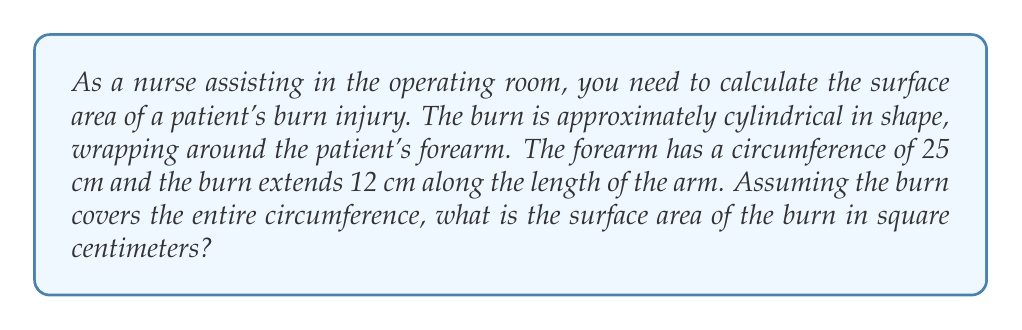Can you answer this question? To solve this problem, we need to use the formula for the surface area of a cylinder, excluding the circular ends:

$$ A = 2\pi rh $$

Where:
$A$ = surface area
$r$ = radius of the cylinder
$h$ = height (length) of the cylinder

Given:
- Circumference of the forearm = 25 cm
- Length of the burn = 12 cm

Step 1: Calculate the radius of the forearm.
We know that circumference = $2\pi r$
$25 = 2\pi r$
$r = \frac{25}{2\pi} \approx 3.98$ cm

Step 2: Apply the surface area formula:
$$ A = 2\pi rh $$
$$ A = 2\pi (3.98)(12) $$
$$ A = 24\pi (3.98) $$
$$ A \approx 300.44 \text{ cm}^2 $$

Therefore, the surface area of the burn is approximately 300.44 square centimeters.
Answer: The surface area of the burn is approximately 300.44 cm². 